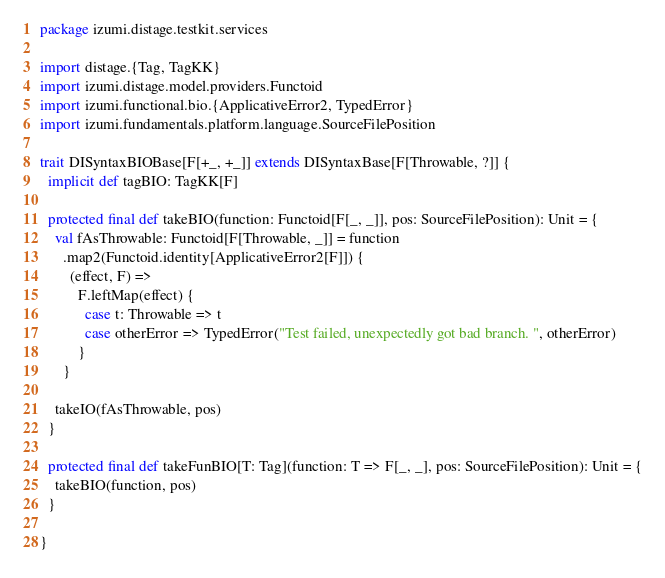Convert code to text. <code><loc_0><loc_0><loc_500><loc_500><_Scala_>package izumi.distage.testkit.services

import distage.{Tag, TagKK}
import izumi.distage.model.providers.Functoid
import izumi.functional.bio.{ApplicativeError2, TypedError}
import izumi.fundamentals.platform.language.SourceFilePosition

trait DISyntaxBIOBase[F[+_, +_]] extends DISyntaxBase[F[Throwable, ?]] {
  implicit def tagBIO: TagKK[F]

  protected final def takeBIO(function: Functoid[F[_, _]], pos: SourceFilePosition): Unit = {
    val fAsThrowable: Functoid[F[Throwable, _]] = function
      .map2(Functoid.identity[ApplicativeError2[F]]) {
        (effect, F) =>
          F.leftMap(effect) {
            case t: Throwable => t
            case otherError => TypedError("Test failed, unexpectedly got bad branch. ", otherError)
          }
      }

    takeIO(fAsThrowable, pos)
  }

  protected final def takeFunBIO[T: Tag](function: T => F[_, _], pos: SourceFilePosition): Unit = {
    takeBIO(function, pos)
  }

}
</code> 